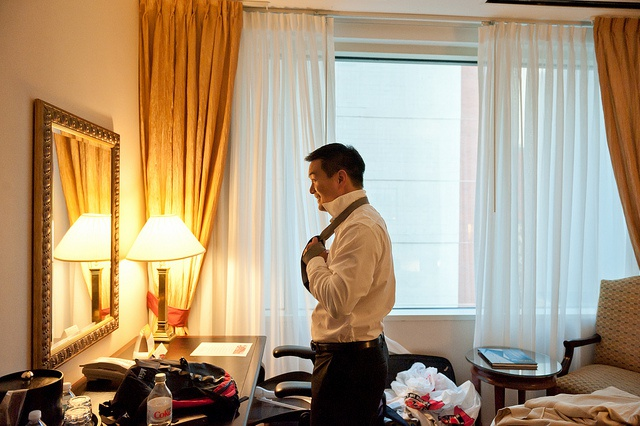Describe the objects in this image and their specific colors. I can see people in brown, black, and tan tones, backpack in olive, black, maroon, tan, and gray tones, chair in olive, maroon, gray, and black tones, chair in olive, black, gray, darkgray, and maroon tones, and bottle in olive, gray, maroon, and tan tones in this image. 